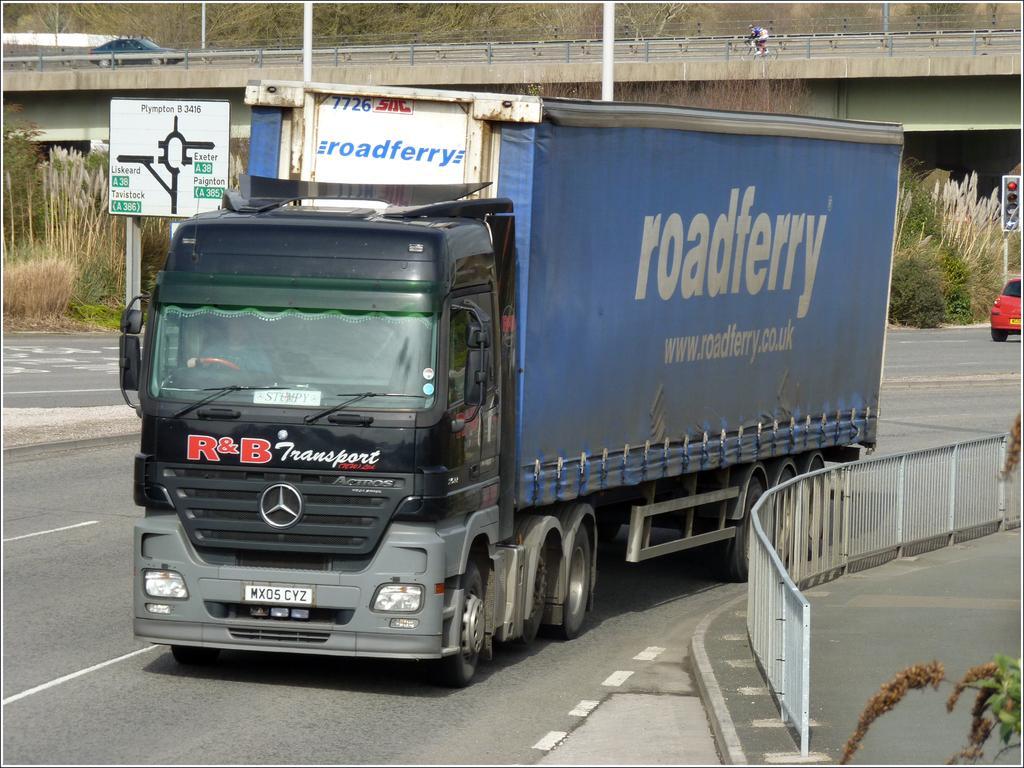Describe this image in one or two sentences. In the picture I can see a truck which has something written on it is on the road and there is a fence beside it and there is a bridge,few plants and some other objects in the background. 